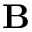Convert formula to latex. <formula><loc_0><loc_0><loc_500><loc_500>{ B }</formula> 